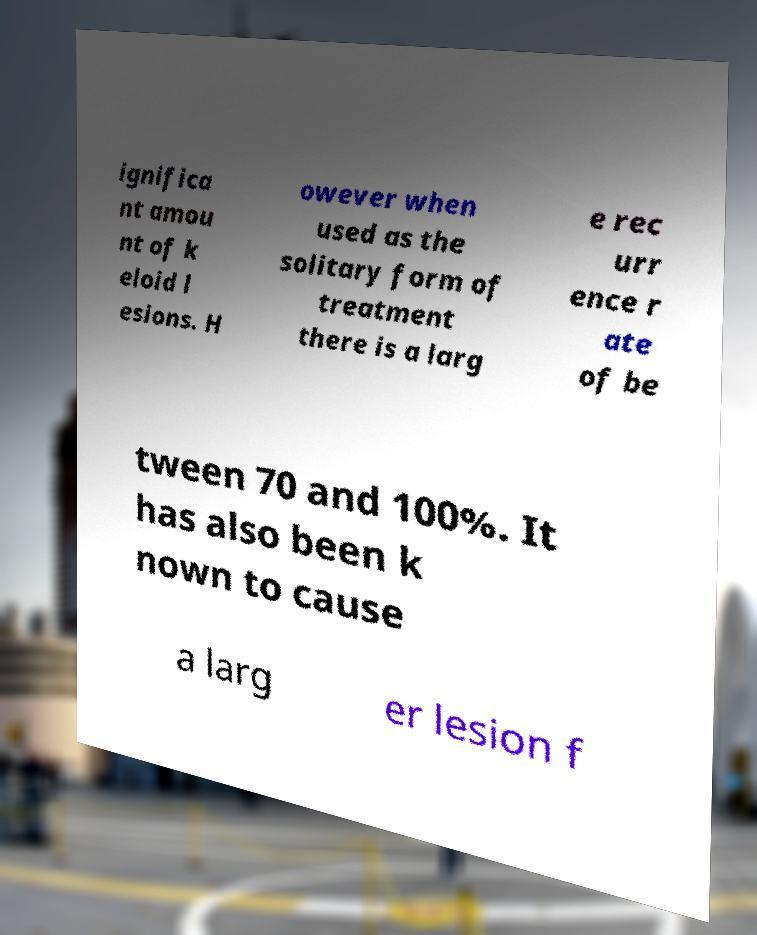Can you read and provide the text displayed in the image?This photo seems to have some interesting text. Can you extract and type it out for me? ignifica nt amou nt of k eloid l esions. H owever when used as the solitary form of treatment there is a larg e rec urr ence r ate of be tween 70 and 100%. It has also been k nown to cause a larg er lesion f 